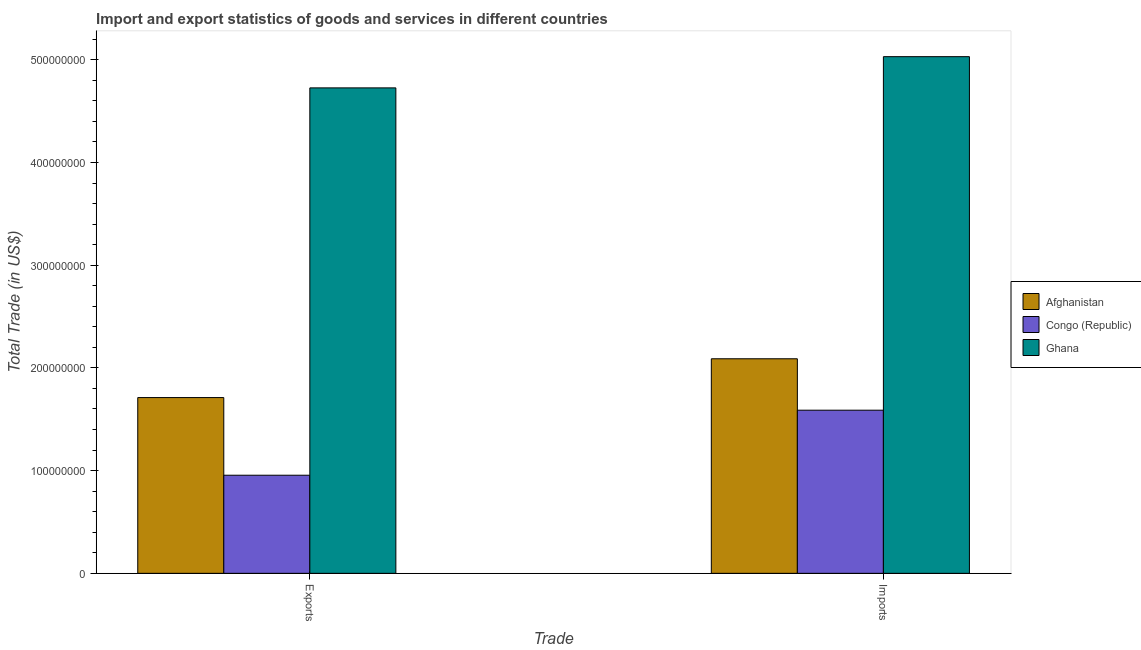How many different coloured bars are there?
Offer a terse response. 3. Are the number of bars per tick equal to the number of legend labels?
Give a very brief answer. Yes. What is the label of the 1st group of bars from the left?
Provide a succinct answer. Exports. What is the imports of goods and services in Afghanistan?
Offer a very short reply. 2.09e+08. Across all countries, what is the maximum export of goods and services?
Your response must be concise. 4.73e+08. Across all countries, what is the minimum export of goods and services?
Provide a succinct answer. 9.55e+07. In which country was the export of goods and services maximum?
Your answer should be compact. Ghana. In which country was the imports of goods and services minimum?
Your answer should be compact. Congo (Republic). What is the total export of goods and services in the graph?
Give a very brief answer. 7.39e+08. What is the difference between the export of goods and services in Congo (Republic) and that in Ghana?
Give a very brief answer. -3.77e+08. What is the difference between the imports of goods and services in Afghanistan and the export of goods and services in Ghana?
Keep it short and to the point. -2.64e+08. What is the average imports of goods and services per country?
Keep it short and to the point. 2.90e+08. What is the difference between the export of goods and services and imports of goods and services in Congo (Republic)?
Give a very brief answer. -6.33e+07. In how many countries, is the imports of goods and services greater than 420000000 US$?
Your answer should be compact. 1. What is the ratio of the export of goods and services in Ghana to that in Afghanistan?
Ensure brevity in your answer.  2.76. What does the 1st bar from the left in Exports represents?
Provide a succinct answer. Afghanistan. What does the 1st bar from the right in Exports represents?
Provide a succinct answer. Ghana. How many bars are there?
Provide a succinct answer. 6. Are all the bars in the graph horizontal?
Your answer should be compact. No. What is the difference between two consecutive major ticks on the Y-axis?
Provide a short and direct response. 1.00e+08. Does the graph contain any zero values?
Provide a succinct answer. No. Does the graph contain grids?
Provide a succinct answer. No. How are the legend labels stacked?
Provide a short and direct response. Vertical. What is the title of the graph?
Make the answer very short. Import and export statistics of goods and services in different countries. Does "Slovenia" appear as one of the legend labels in the graph?
Give a very brief answer. No. What is the label or title of the X-axis?
Keep it short and to the point. Trade. What is the label or title of the Y-axis?
Make the answer very short. Total Trade (in US$). What is the Total Trade (in US$) of Afghanistan in Exports?
Make the answer very short. 1.71e+08. What is the Total Trade (in US$) of Congo (Republic) in Exports?
Make the answer very short. 9.55e+07. What is the Total Trade (in US$) of Ghana in Exports?
Keep it short and to the point. 4.73e+08. What is the Total Trade (in US$) in Afghanistan in Imports?
Offer a very short reply. 2.09e+08. What is the Total Trade (in US$) of Congo (Republic) in Imports?
Offer a terse response. 1.59e+08. What is the Total Trade (in US$) in Ghana in Imports?
Give a very brief answer. 5.03e+08. Across all Trade, what is the maximum Total Trade (in US$) of Afghanistan?
Your answer should be very brief. 2.09e+08. Across all Trade, what is the maximum Total Trade (in US$) of Congo (Republic)?
Provide a succinct answer. 1.59e+08. Across all Trade, what is the maximum Total Trade (in US$) in Ghana?
Make the answer very short. 5.03e+08. Across all Trade, what is the minimum Total Trade (in US$) in Afghanistan?
Give a very brief answer. 1.71e+08. Across all Trade, what is the minimum Total Trade (in US$) of Congo (Republic)?
Make the answer very short. 9.55e+07. Across all Trade, what is the minimum Total Trade (in US$) in Ghana?
Keep it short and to the point. 4.73e+08. What is the total Total Trade (in US$) in Afghanistan in the graph?
Offer a terse response. 3.80e+08. What is the total Total Trade (in US$) of Congo (Republic) in the graph?
Make the answer very short. 2.54e+08. What is the total Total Trade (in US$) in Ghana in the graph?
Give a very brief answer. 9.76e+08. What is the difference between the Total Trade (in US$) of Afghanistan in Exports and that in Imports?
Offer a terse response. -3.78e+07. What is the difference between the Total Trade (in US$) in Congo (Republic) in Exports and that in Imports?
Your answer should be compact. -6.33e+07. What is the difference between the Total Trade (in US$) of Ghana in Exports and that in Imports?
Offer a very short reply. -3.04e+07. What is the difference between the Total Trade (in US$) of Afghanistan in Exports and the Total Trade (in US$) of Congo (Republic) in Imports?
Make the answer very short. 1.23e+07. What is the difference between the Total Trade (in US$) in Afghanistan in Exports and the Total Trade (in US$) in Ghana in Imports?
Offer a very short reply. -3.32e+08. What is the difference between the Total Trade (in US$) of Congo (Republic) in Exports and the Total Trade (in US$) of Ghana in Imports?
Your answer should be very brief. -4.08e+08. What is the average Total Trade (in US$) of Afghanistan per Trade?
Give a very brief answer. 1.90e+08. What is the average Total Trade (in US$) of Congo (Republic) per Trade?
Provide a succinct answer. 1.27e+08. What is the average Total Trade (in US$) in Ghana per Trade?
Provide a succinct answer. 4.88e+08. What is the difference between the Total Trade (in US$) of Afghanistan and Total Trade (in US$) of Congo (Republic) in Exports?
Your answer should be very brief. 7.56e+07. What is the difference between the Total Trade (in US$) of Afghanistan and Total Trade (in US$) of Ghana in Exports?
Your answer should be compact. -3.02e+08. What is the difference between the Total Trade (in US$) of Congo (Republic) and Total Trade (in US$) of Ghana in Exports?
Provide a short and direct response. -3.77e+08. What is the difference between the Total Trade (in US$) in Afghanistan and Total Trade (in US$) in Congo (Republic) in Imports?
Your answer should be compact. 5.01e+07. What is the difference between the Total Trade (in US$) in Afghanistan and Total Trade (in US$) in Ghana in Imports?
Ensure brevity in your answer.  -2.94e+08. What is the difference between the Total Trade (in US$) of Congo (Republic) and Total Trade (in US$) of Ghana in Imports?
Provide a short and direct response. -3.44e+08. What is the ratio of the Total Trade (in US$) in Afghanistan in Exports to that in Imports?
Provide a succinct answer. 0.82. What is the ratio of the Total Trade (in US$) of Congo (Republic) in Exports to that in Imports?
Offer a terse response. 0.6. What is the ratio of the Total Trade (in US$) in Ghana in Exports to that in Imports?
Your answer should be very brief. 0.94. What is the difference between the highest and the second highest Total Trade (in US$) of Afghanistan?
Make the answer very short. 3.78e+07. What is the difference between the highest and the second highest Total Trade (in US$) in Congo (Republic)?
Give a very brief answer. 6.33e+07. What is the difference between the highest and the second highest Total Trade (in US$) in Ghana?
Keep it short and to the point. 3.04e+07. What is the difference between the highest and the lowest Total Trade (in US$) of Afghanistan?
Offer a very short reply. 3.78e+07. What is the difference between the highest and the lowest Total Trade (in US$) in Congo (Republic)?
Ensure brevity in your answer.  6.33e+07. What is the difference between the highest and the lowest Total Trade (in US$) in Ghana?
Make the answer very short. 3.04e+07. 